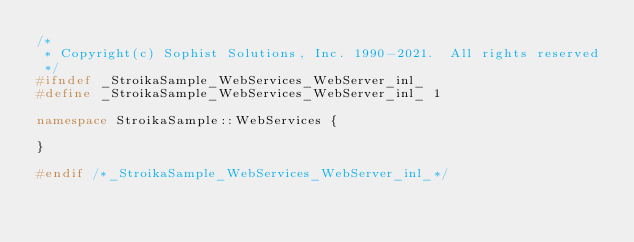Convert code to text. <code><loc_0><loc_0><loc_500><loc_500><_C++_>/*
 * Copyright(c) Sophist Solutions, Inc. 1990-2021.  All rights reserved
 */
#ifndef _StroikaSample_WebServices_WebServer_inl_
#define _StroikaSample_WebServices_WebServer_inl_ 1

namespace StroikaSample::WebServices {

}

#endif /*_StroikaSample_WebServices_WebServer_inl_*/
</code> 